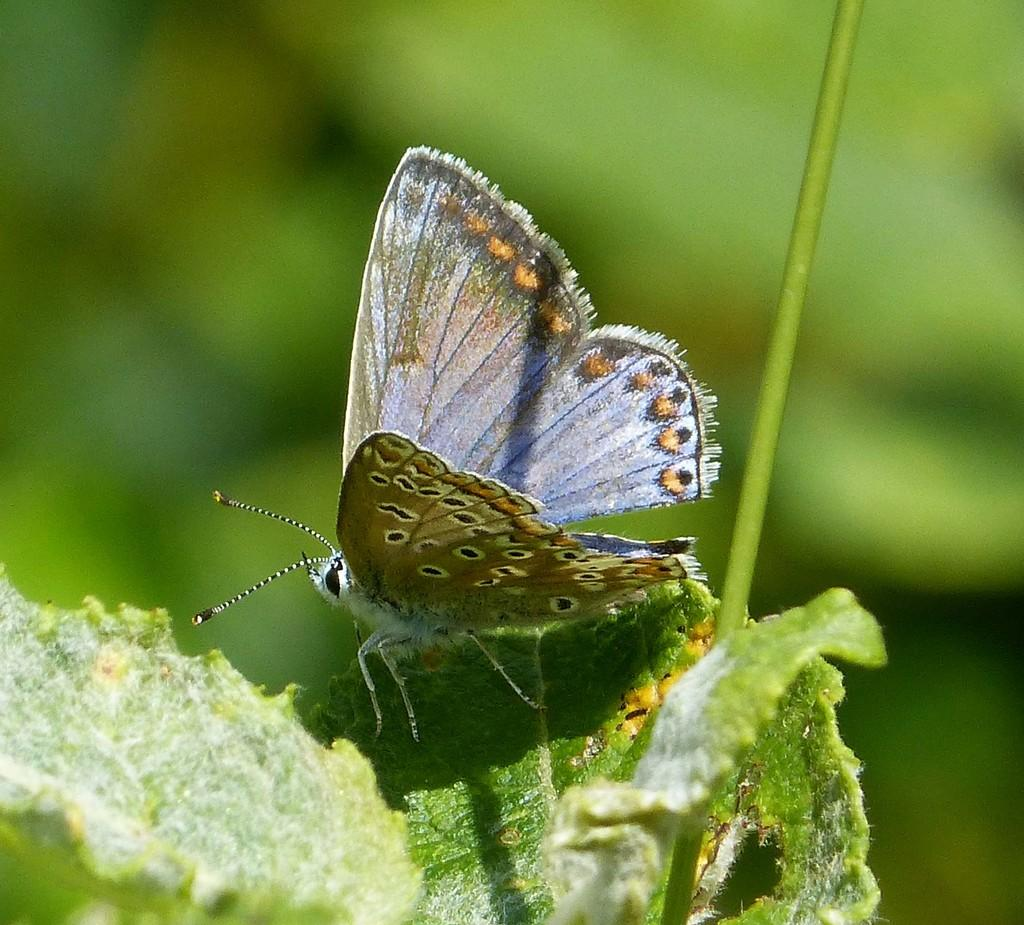What is the main subject of the image? The main subject of the image is a butterfly. Where is the butterfly located in the image? The butterfly is on a leaf in the image. Reasoning: Let'g: Let's think step by step in order to produce the conversation. We start by identifying the main subject of the image, which is the butterfly. Then, we describe the location of the butterfly, which is on a leaf. Each question is designed to elicit a specific detail about the image that is known from the provided facts. Absurd Question/Answer: What type of bird can be seen flying in the image? There is no bird present in the image; it features a butterfly on a leaf. What angle is the butterfly positioned at in the image? The angle at which the butterfly is positioned cannot be determined from the image alone, as it depends on the perspective of the viewer. What force is acting on the butterfly in the image? There is no information about any force acting on the butterfly in the image. The butterfly is simply resting on a leaf. 